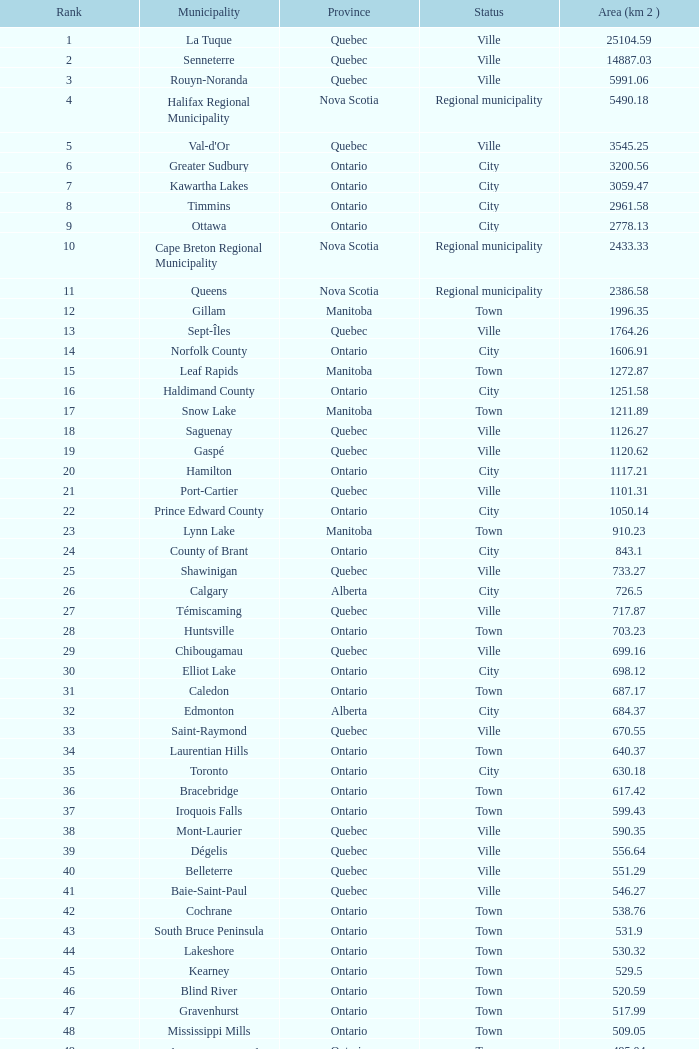What's the combined rank with an area (km 2) of 105 22.0. 